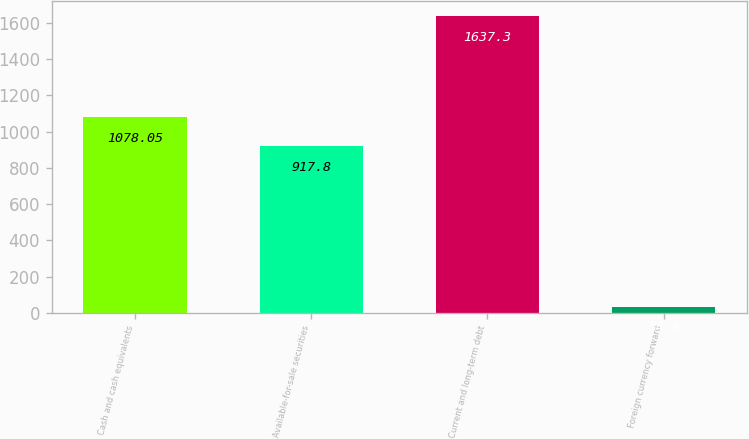<chart> <loc_0><loc_0><loc_500><loc_500><bar_chart><fcel>Cash and cash equivalents<fcel>Available-for-sale securities<fcel>Current and long-term debt<fcel>Foreign currency forward<nl><fcel>1078.05<fcel>917.8<fcel>1637.3<fcel>34.8<nl></chart> 